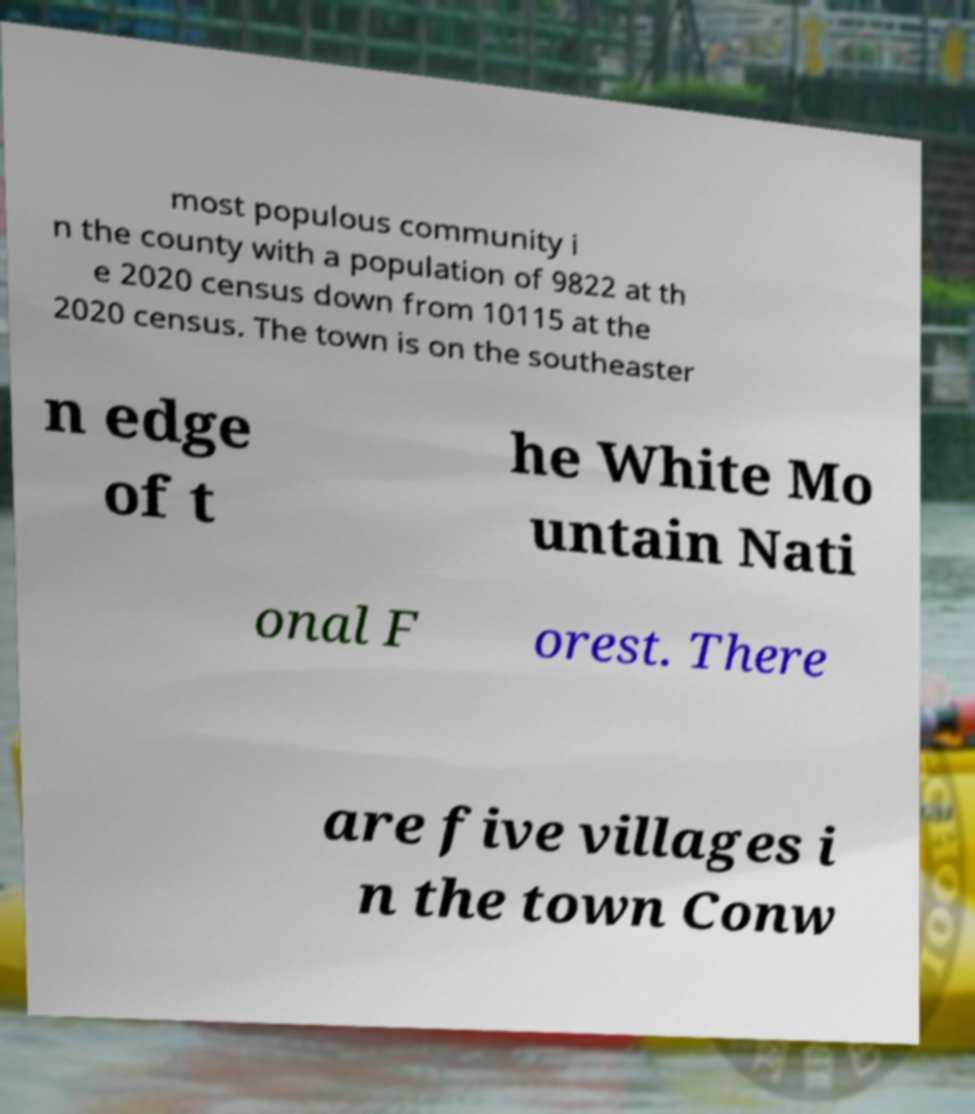Please identify and transcribe the text found in this image. most populous community i n the county with a population of 9822 at th e 2020 census down from 10115 at the 2020 census. The town is on the southeaster n edge of t he White Mo untain Nati onal F orest. There are five villages i n the town Conw 